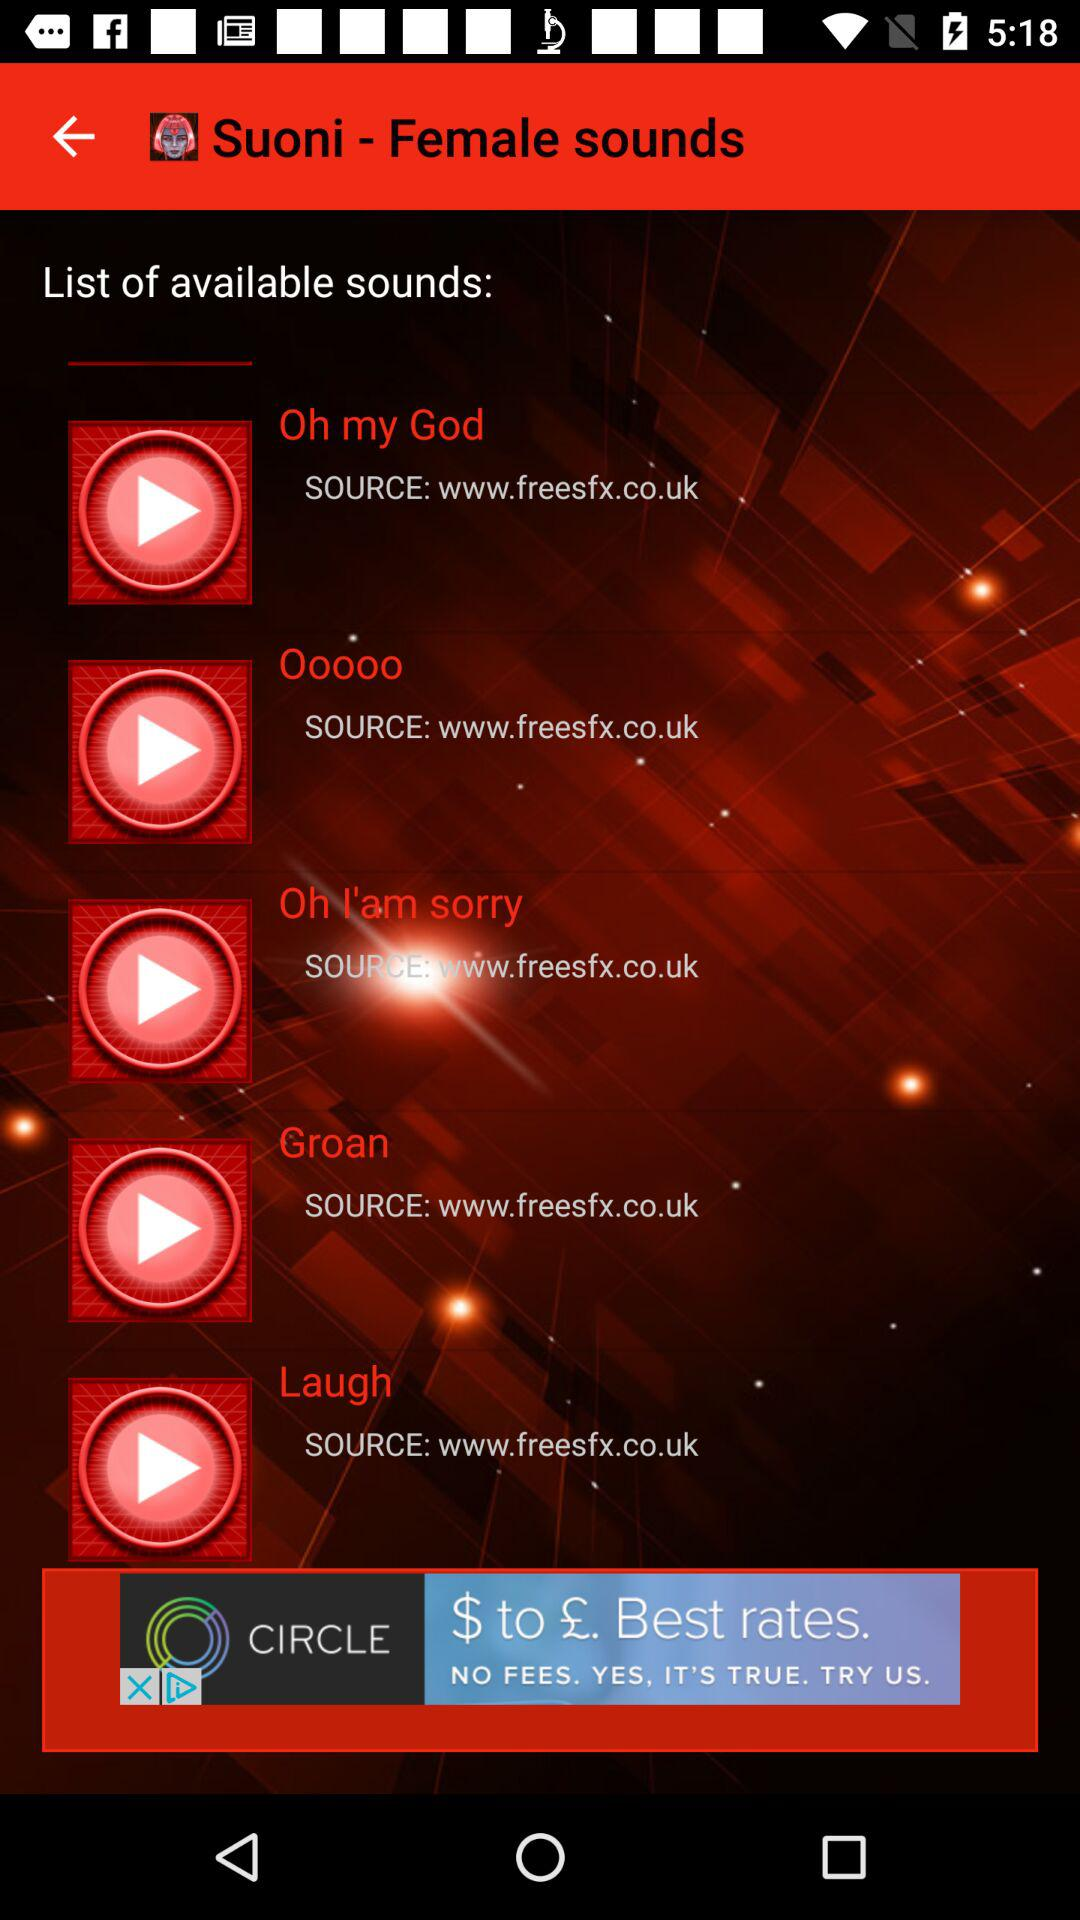How many sounds are available?
Answer the question using a single word or phrase. 5 